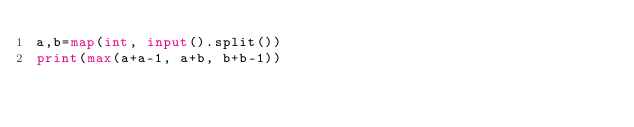<code> <loc_0><loc_0><loc_500><loc_500><_Python_>a,b=map(int, input().split())
print(max(a+a-1, a+b, b+b-1))</code> 